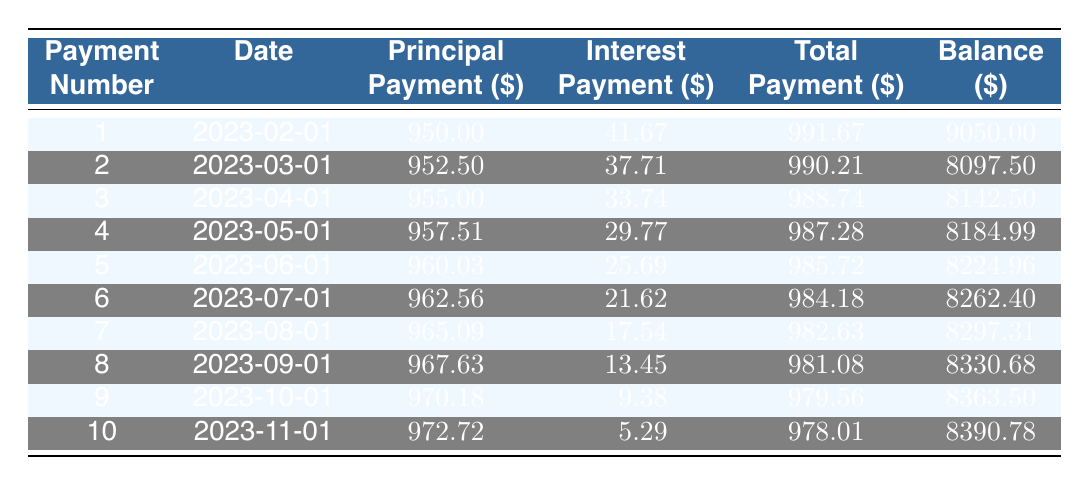What is the total payment for the first month? From the table, the total payment for the first month (Payment Number 1) is directly listed as 991.67.
Answer: 991.67 What is the principal payment amount in the 5th installment? The table shows that in the 5th installment (Payment Number 5), the principal payment amount is 960.03.
Answer: 960.03 Is the interest payment on the 6th installment less than that of the 2nd installment? The interest payment in the 6th installment is 21.62, while in the 2nd installment, it is 37.71. Since 21.62 is less than 37.71, the statement is true.
Answer: Yes What is the remaining balance after the 10th payment? The remaining balance after the 10th payment (Payment Number 10) is shown in the table as 8390.78.
Answer: 8390.78 What is the average total payment over the first ten installments? To find the average total payment, sum the total payments for the first ten installments: (991.67 + 990.21 + 988.74 + 987.28 + 985.72 + 984.18 + 982.63 + 981.08 + 979.56 + 978.01) = 9788.09. Dividing by 10 gives 978.81 as the average total payment.
Answer: 978.81 What is the difference between the principal payment of the 3rd and 8th payments? The principal payment in the 3rd installment is 955.00 and in the 8th installment is 967.63. The difference is 967.63 - 955.00 = 12.63.
Answer: 12.63 Which payment number has the highest interest payment? By examining the interest payments in the table, the highest interest payment is associated with the 1st payment, which is 41.67.
Answer: 1 What is the total principal paid after the first three installments? To calculate the total principal paid after the first three installments, add the principal payments from the first three months: 950.00 + 952.50 + 955.00 = 2857.50.
Answer: 2857.50 Is the total payment in the 9th installment more than the average total payment of the first ten payments? The 9th installment total payment is 979.56, while the average total payment is 978.81. Since 979.56 > 978.81, the answer is yes.
Answer: Yes 